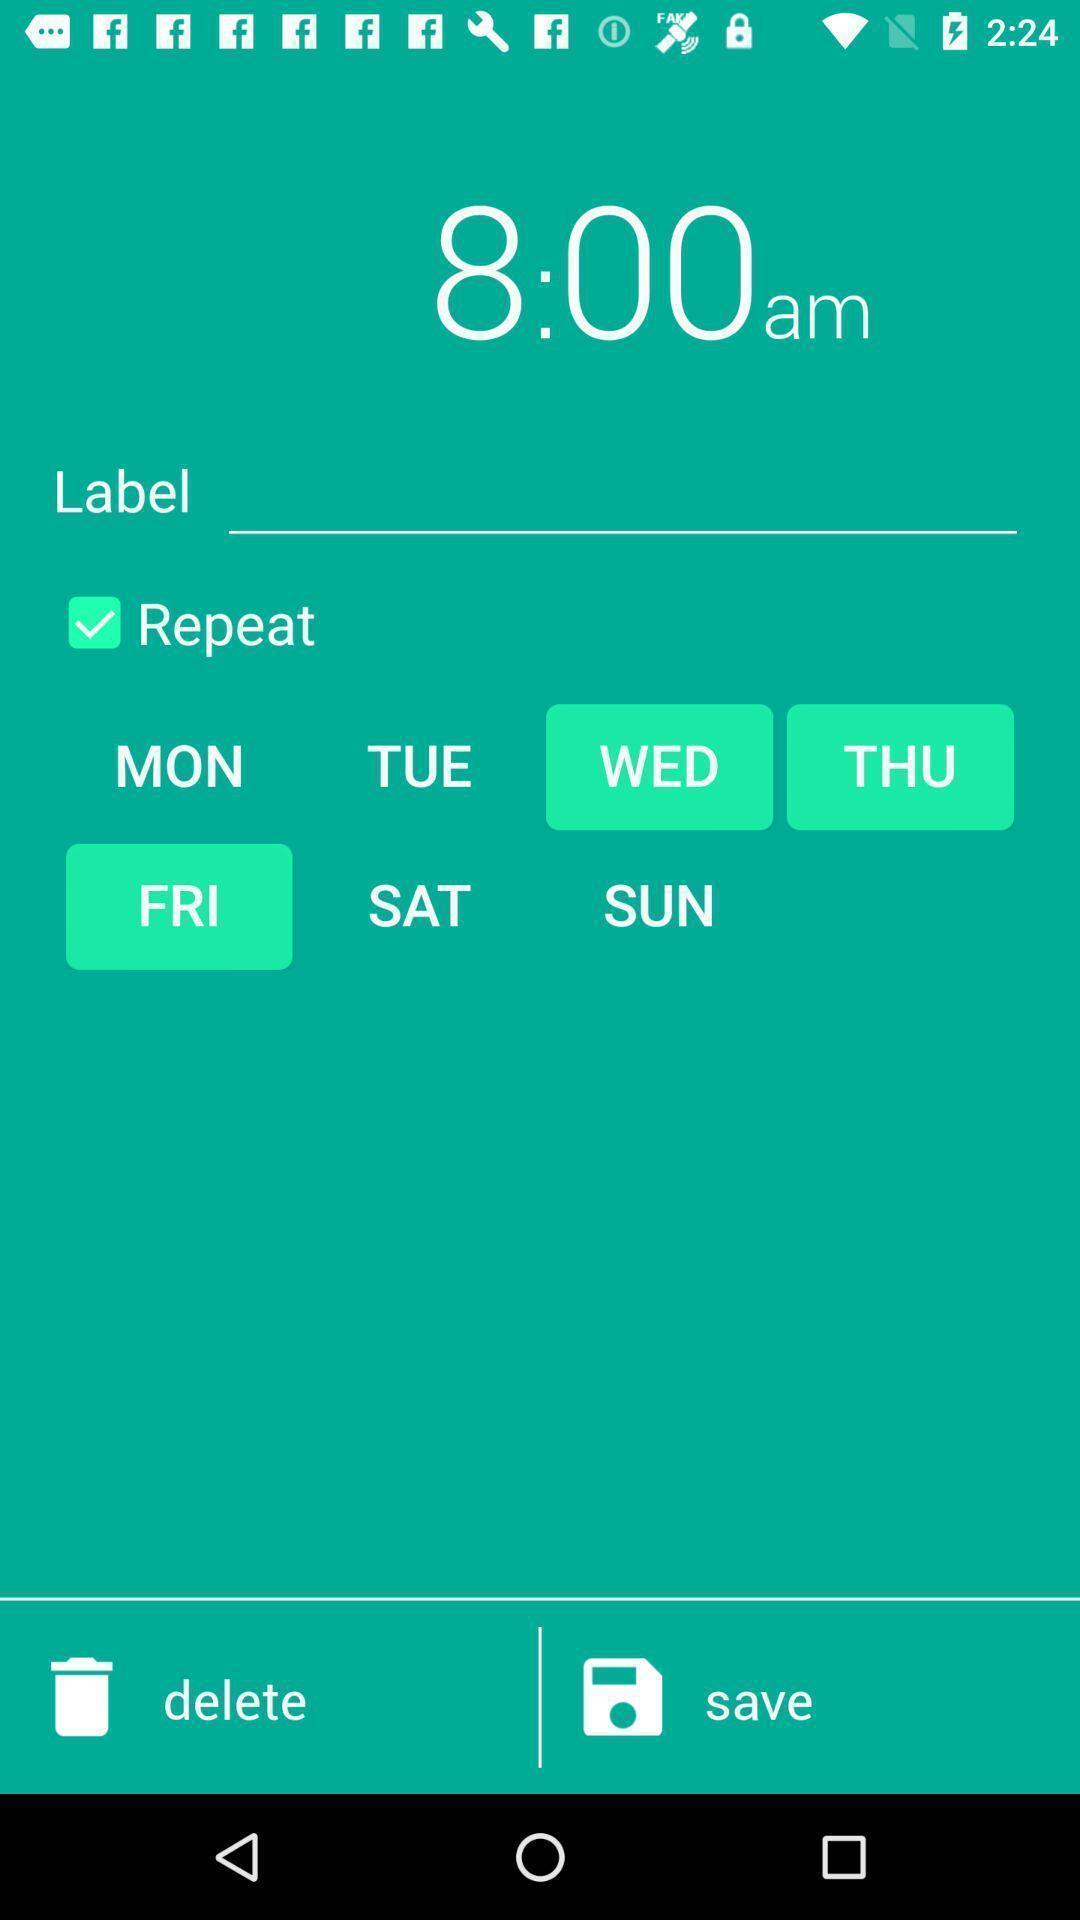Provide a detailed account of this screenshot. Screen display alarm settings option. 